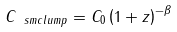Convert formula to latex. <formula><loc_0><loc_0><loc_500><loc_500>C _ { \ s m { c l u m p } } = C _ { 0 } \left ( 1 + z \right ) ^ { - \beta }</formula> 